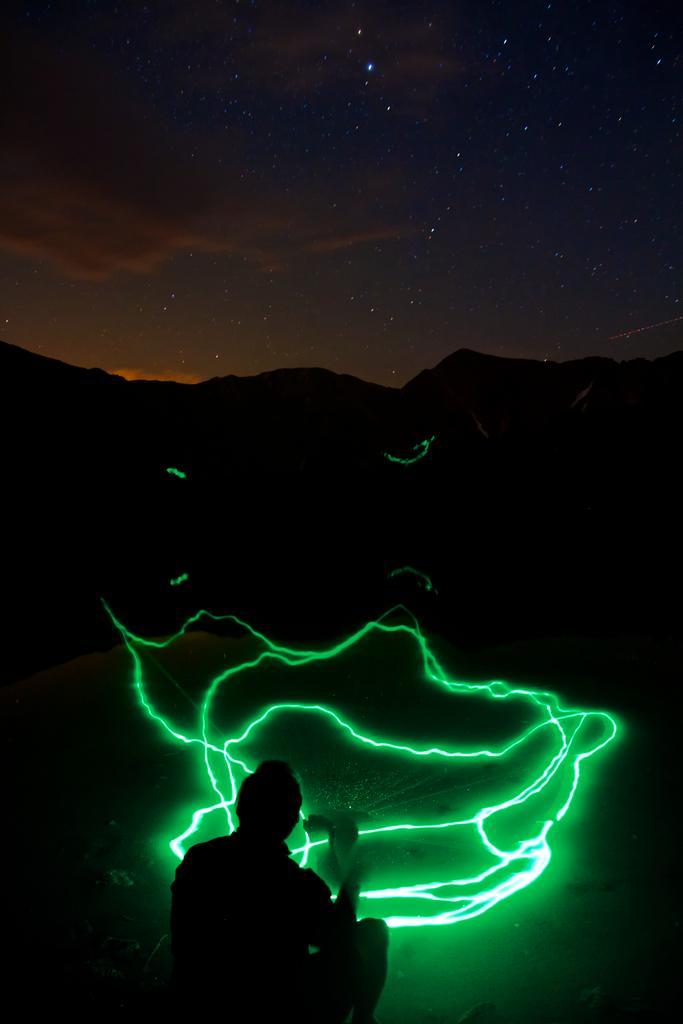In one or two sentences, can you explain what this image depicts? In this image, we can see the background is dark. Top of the image, we can see the sky with stars. At the bottom, we can see a laser light in green color. Here we can see a person. 